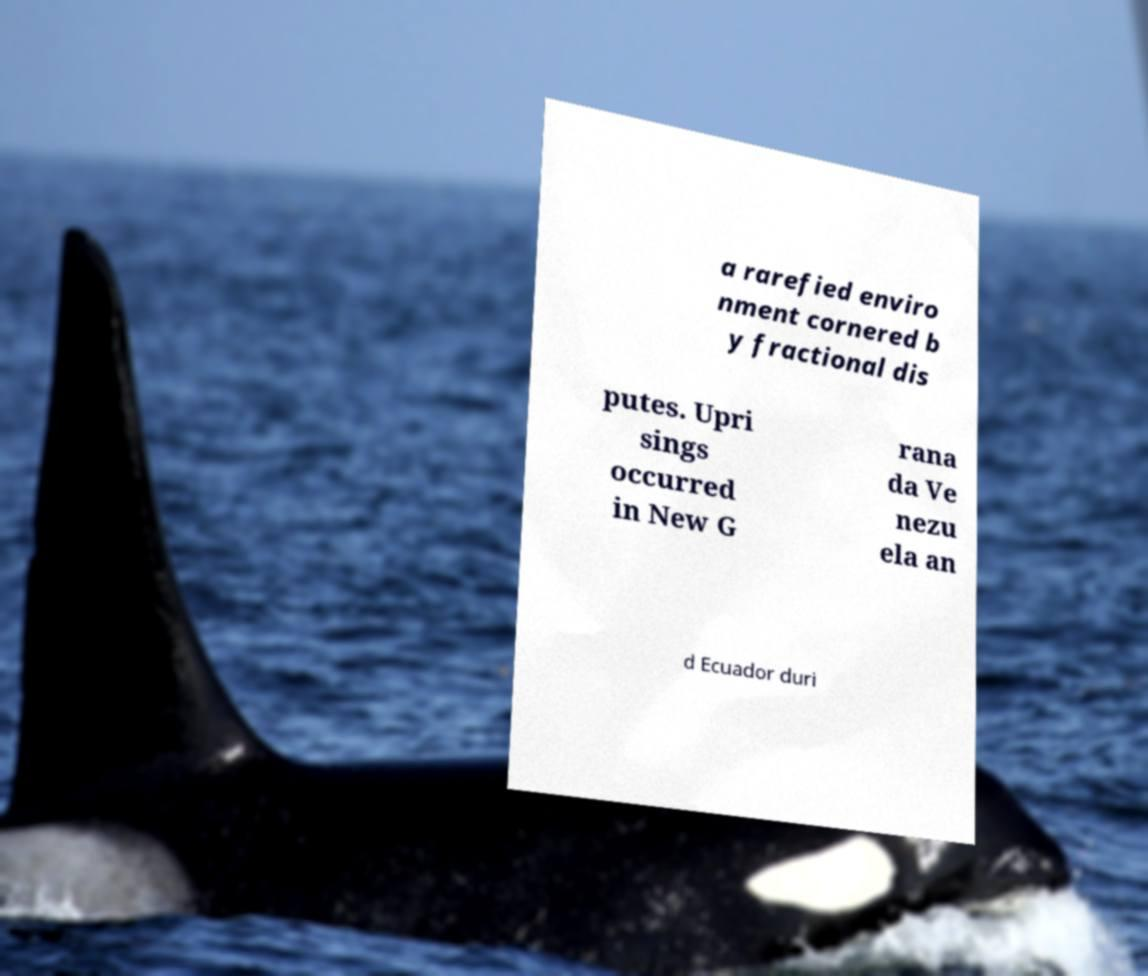Please identify and transcribe the text found in this image. a rarefied enviro nment cornered b y fractional dis putes. Upri sings occurred in New G rana da Ve nezu ela an d Ecuador duri 